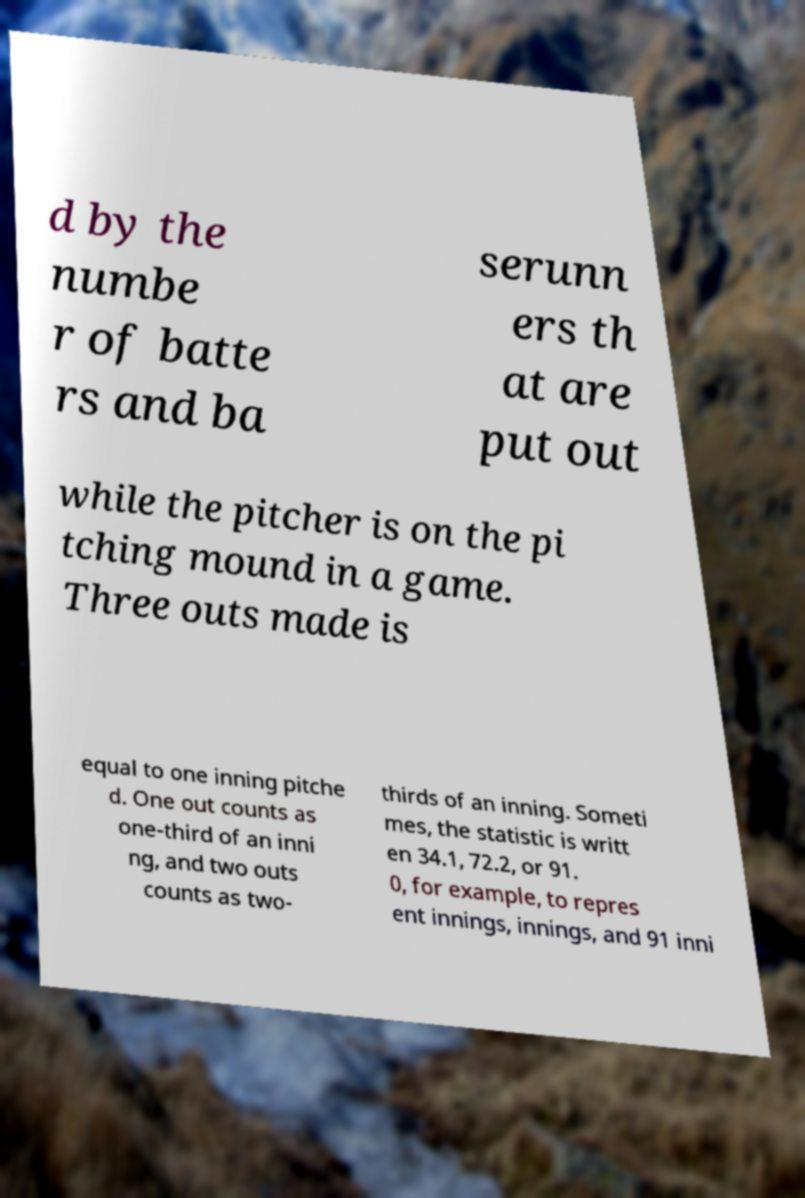For documentation purposes, I need the text within this image transcribed. Could you provide that? d by the numbe r of batte rs and ba serunn ers th at are put out while the pitcher is on the pi tching mound in a game. Three outs made is equal to one inning pitche d. One out counts as one-third of an inni ng, and two outs counts as two- thirds of an inning. Someti mes, the statistic is writt en 34.1, 72.2, or 91. 0, for example, to repres ent innings, innings, and 91 inni 